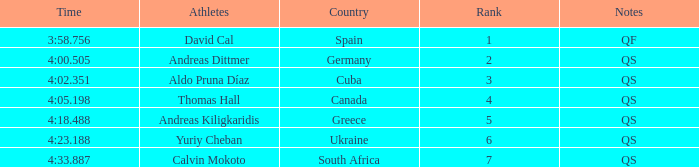What are the notes for the athlete from South Africa? QS. 